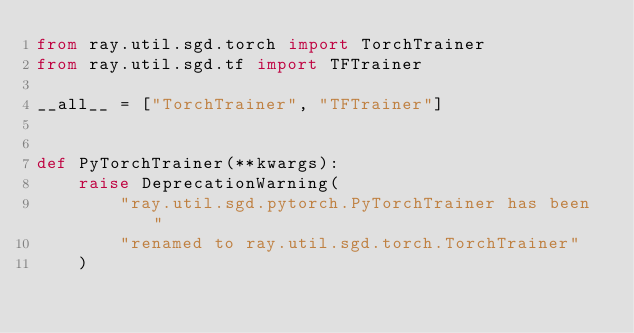Convert code to text. <code><loc_0><loc_0><loc_500><loc_500><_Python_>from ray.util.sgd.torch import TorchTrainer
from ray.util.sgd.tf import TFTrainer

__all__ = ["TorchTrainer", "TFTrainer"]


def PyTorchTrainer(**kwargs):
    raise DeprecationWarning(
        "ray.util.sgd.pytorch.PyTorchTrainer has been "
        "renamed to ray.util.sgd.torch.TorchTrainer"
    )
</code> 